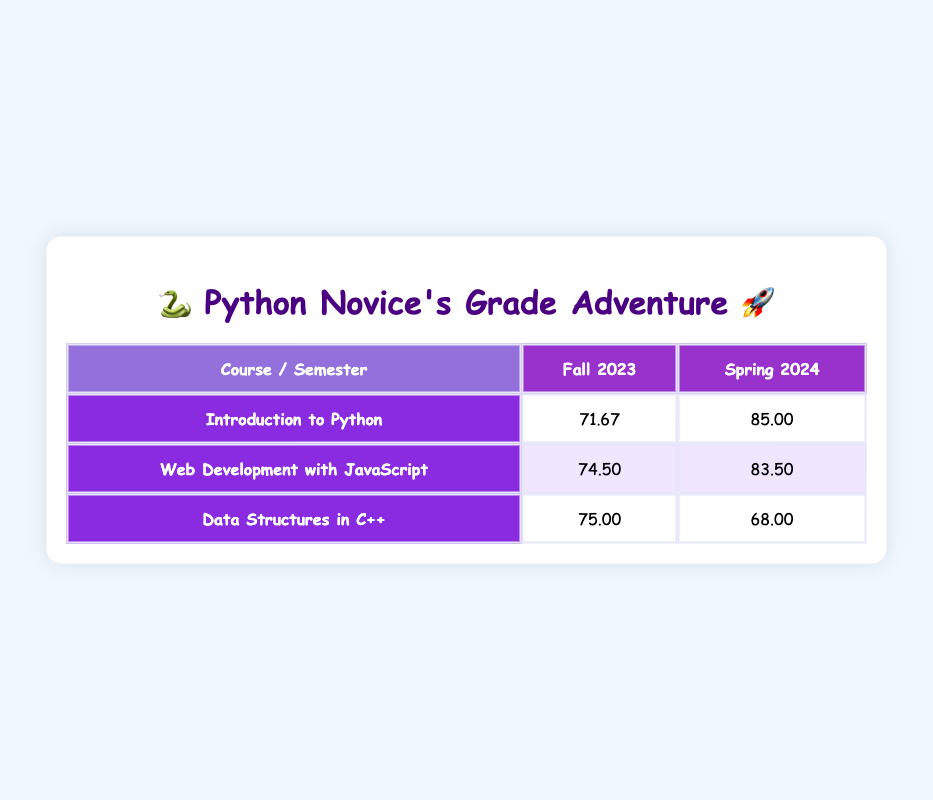What is the average grade for "Introduction to Python" in Fall 2023? The grades for Fall 2023 in "Introduction to Python" are 78, 65, and 72. To find the average, add these grades: 78 + 65 + 72 = 215. Then divide by the number of grades: 215 / 3 = 71.67.
Answer: 71.67 What is the highest grade in "Web Development with JavaScript"? The grades for "Web Development with JavaScript" are 76 and 85. The highest grade is 85, which comes from the Spring 2024 semester.
Answer: 85 Did any student score higher than 80 in "Data Structures in C++" during Fall 2023? The grades for "Data Structures in C++" in Fall 2023 are 71 and 79. Both are below 80, so no student scored higher than 80 in this course during that semester.
Answer: No What is the overall average grade for the course "Web Development with JavaScript"? The grades for "Web Development with JavaScript" are 76 (Fall 2023) and 85 (Spring 2024). To calculate the average, sum the grades: 76 + 85 = 161. Then divide by the number of semesters: 161 / 2 = 80.5.
Answer: 80.5 In which semester did "Data Structures in C++" have a lower average grade? The average for "Data Structures in C++" in Fall 2023 is 75, while in Spring 2024, it is 68. Since 68 is lower than 75, it had a lower average in Spring 2024.
Answer: Spring 2024 What is the average grade across all courses for Fall 2023? For Fall 2023, the grades are: 78 (Introduction to Python), 65 (Introduction to Python), 71 (Data Structures in C++), 76 (Web Development with JavaScript), 72 (Introduction to Python), and 79 (Data Structures in C++). The sum is 78 + 65 + 71 + 76 + 72 + 79 = 441. There are 6 grades, therefore: 441 / 6 = 73.5.
Answer: 73.5 